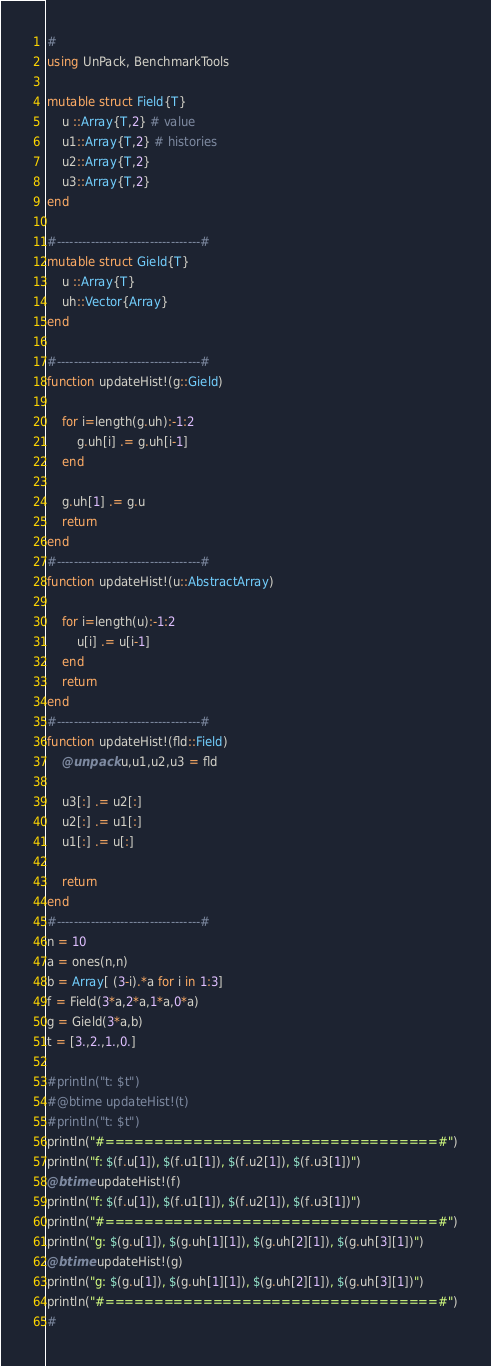Convert code to text. <code><loc_0><loc_0><loc_500><loc_500><_Julia_>#
using UnPack, BenchmarkTools

mutable struct Field{T}
    u ::Array{T,2} # value
    u1::Array{T,2} # histories
    u2::Array{T,2}
    u3::Array{T,2}
end

#----------------------------------#
mutable struct Gield{T}
    u ::Array{T}
    uh::Vector{Array}
end

#----------------------------------#
function updateHist!(g::Gield)

    for i=length(g.uh):-1:2
        g.uh[i] .= g.uh[i-1]
    end

    g.uh[1] .= g.u
    return
end
#----------------------------------#
function updateHist!(u::AbstractArray)

    for i=length(u):-1:2
        u[i] .= u[i-1]
    end
    return
end
#----------------------------------#
function updateHist!(fld::Field)
    @unpack u,u1,u2,u3 = fld

    u3[:] .= u2[:]
    u2[:] .= u1[:]
    u1[:] .= u[:]

    return
end
#----------------------------------#
n = 10
a = ones(n,n)
b = Array[ (3-i).*a for i in 1:3]
f = Field(3*a,2*a,1*a,0*a)
g = Gield(3*a,b)
t = [3.,2.,1.,0.]

#println("t: $t")
#@btime updateHist!(t)
#println("t: $t")
println("#==================================#")
println("f: $(f.u[1]), $(f.u1[1]), $(f.u2[1]), $(f.u3[1])")
@btime updateHist!(f)
println("f: $(f.u[1]), $(f.u1[1]), $(f.u2[1]), $(f.u3[1])")
println("#==================================#")
println("g: $(g.u[1]), $(g.uh[1][1]), $(g.uh[2][1]), $(g.uh[3][1])")
@btime updateHist!(g)
println("g: $(g.u[1]), $(g.uh[1][1]), $(g.uh[2][1]), $(g.uh[3][1])")
println("#==================================#")
#
</code> 